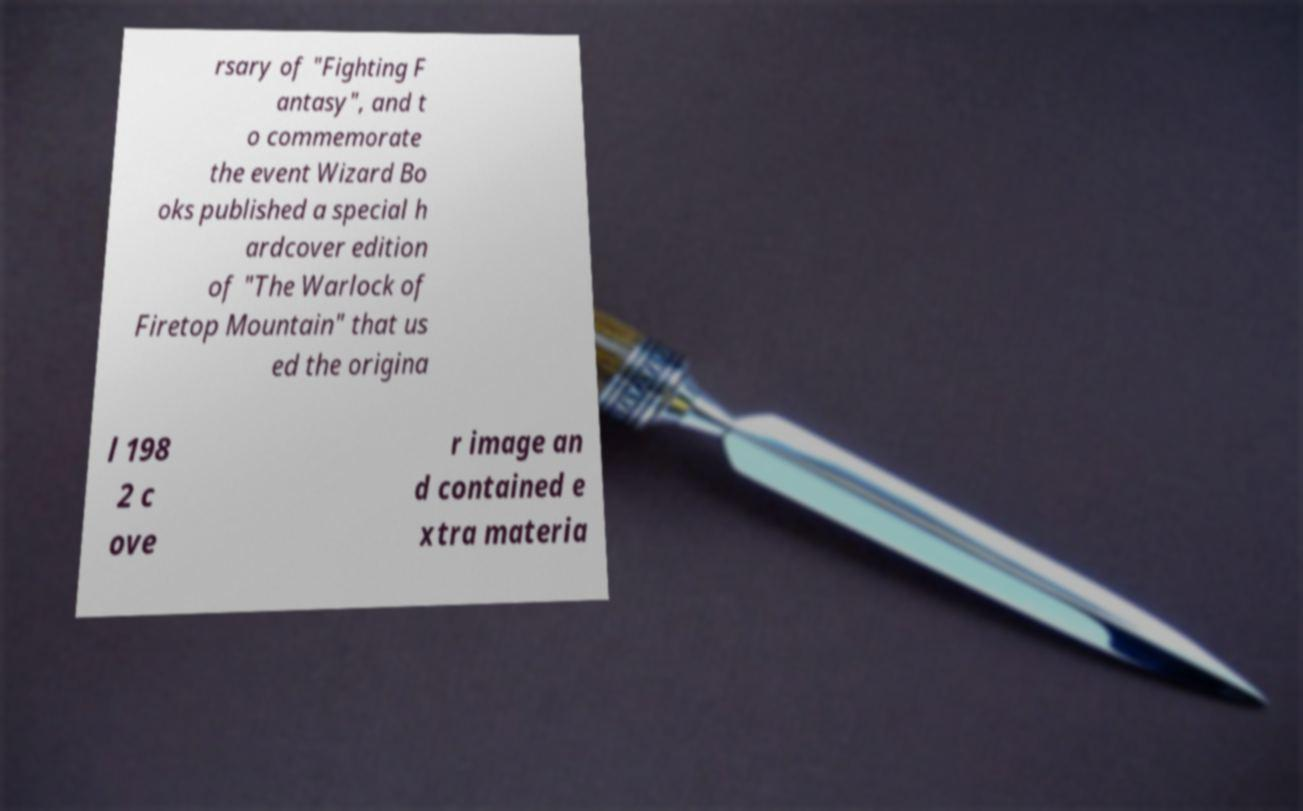Can you read and provide the text displayed in the image?This photo seems to have some interesting text. Can you extract and type it out for me? rsary of "Fighting F antasy", and t o commemorate the event Wizard Bo oks published a special h ardcover edition of "The Warlock of Firetop Mountain" that us ed the origina l 198 2 c ove r image an d contained e xtra materia 